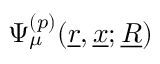<formula> <loc_0><loc_0><loc_500><loc_500>\Psi _ { \mu } ^ { ( p ) } ( \underline { r } , \underline { x } ; \underline { R } )</formula> 